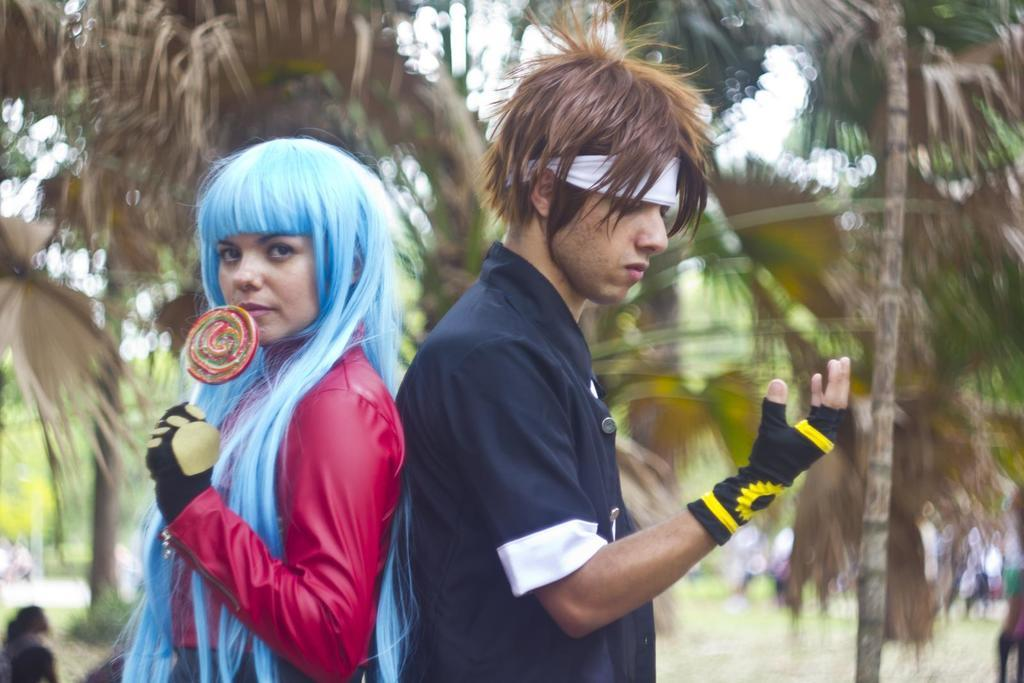How many people are present in the image? There are two people, a man and a woman, present in the image. What is the woman holding in the image? The woman is holding a lollipop. What can be seen in the background of the image? There are trees and people in the background of the image. How would you describe the background of the image? The background of the image is blurry. What type of lettuce can be seen growing on the trees in the background? There is no lettuce visible on the trees in the background; they are simply trees. Can you see any ants crawling on the lollipop in the image? There is no indication of ants in the image, and the focus is on the lollipop being held by the woman. 